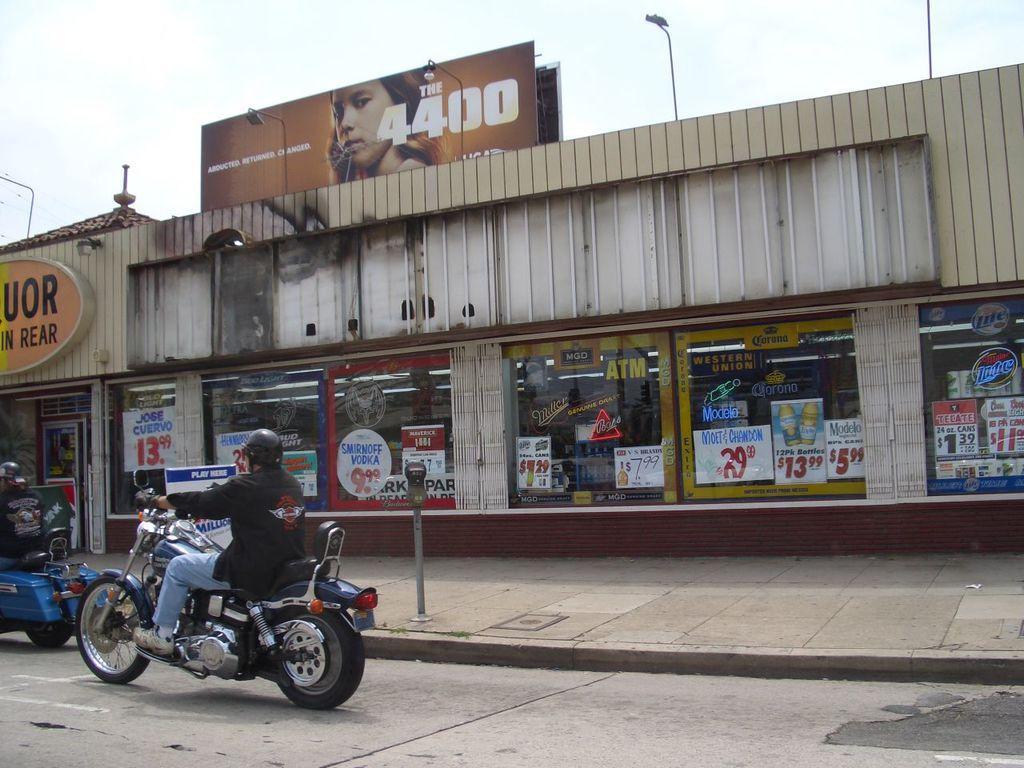Could you give a brief overview of what you see in this image? In this picture I can observe a person driving a bike on the left side. In the middle of the picture I can observe a building which is looking like a store. There are some posters on the glass walls of the store. In the top of the picture I can observe an advertisement stand. In the background I can observe sky. 